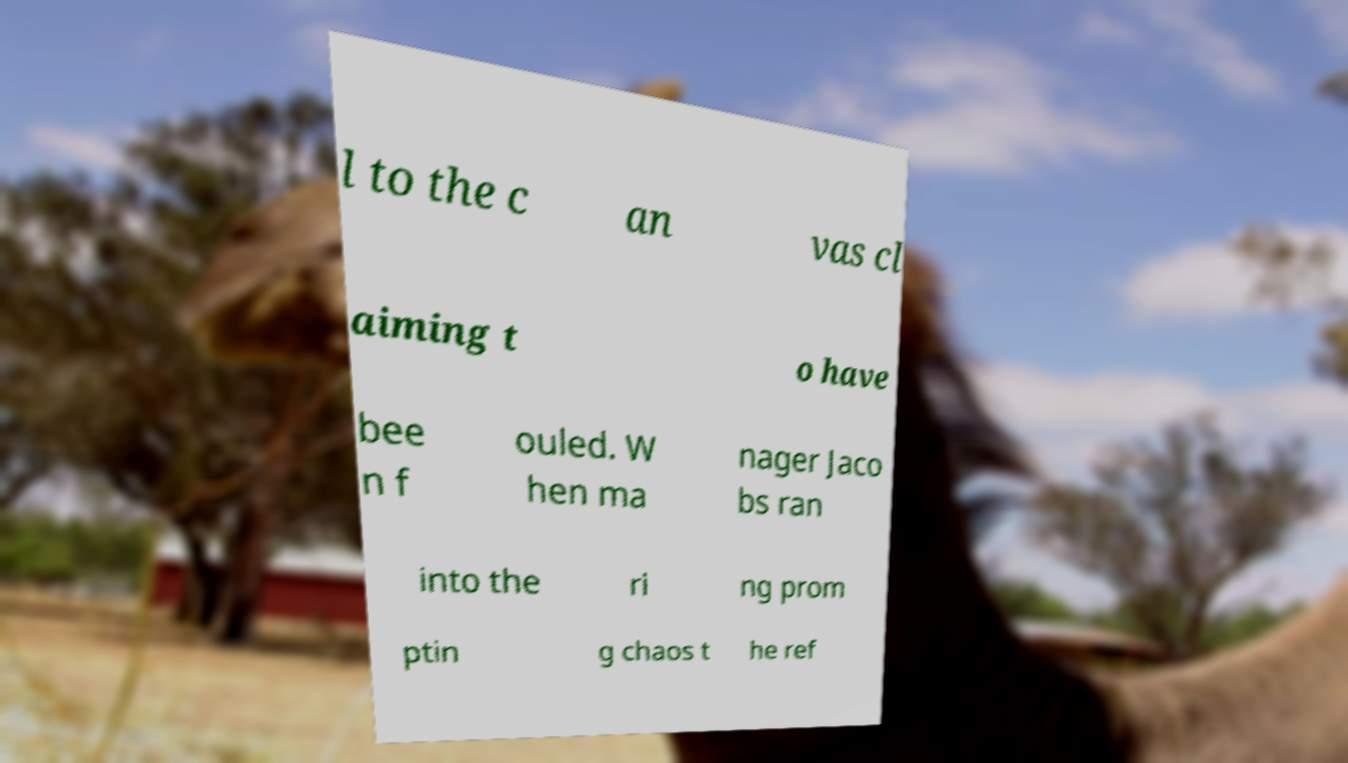Can you accurately transcribe the text from the provided image for me? l to the c an vas cl aiming t o have bee n f ouled. W hen ma nager Jaco bs ran into the ri ng prom ptin g chaos t he ref 